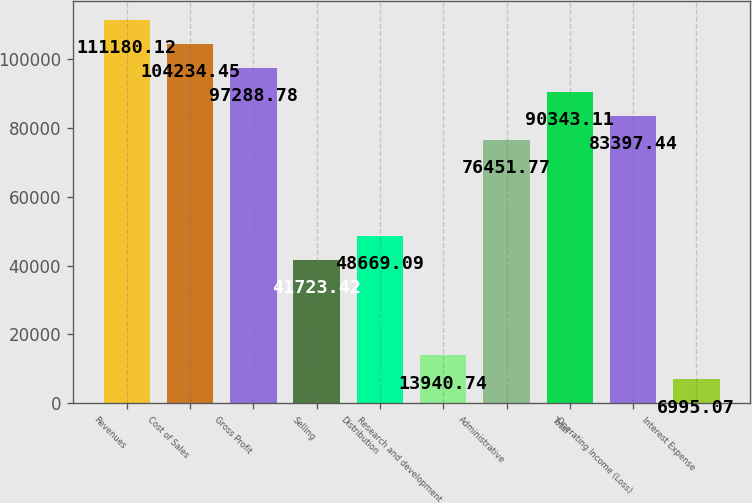Convert chart. <chart><loc_0><loc_0><loc_500><loc_500><bar_chart><fcel>Revenues<fcel>Cost of Sales<fcel>Gross Profit<fcel>Selling<fcel>Distribution<fcel>Research and development<fcel>Administrative<fcel>Total<fcel>Operating Income (Loss)<fcel>Interest Expense<nl><fcel>111180<fcel>104234<fcel>97288.8<fcel>41723.4<fcel>48669.1<fcel>13940.7<fcel>76451.8<fcel>90343.1<fcel>83397.4<fcel>6995.07<nl></chart> 